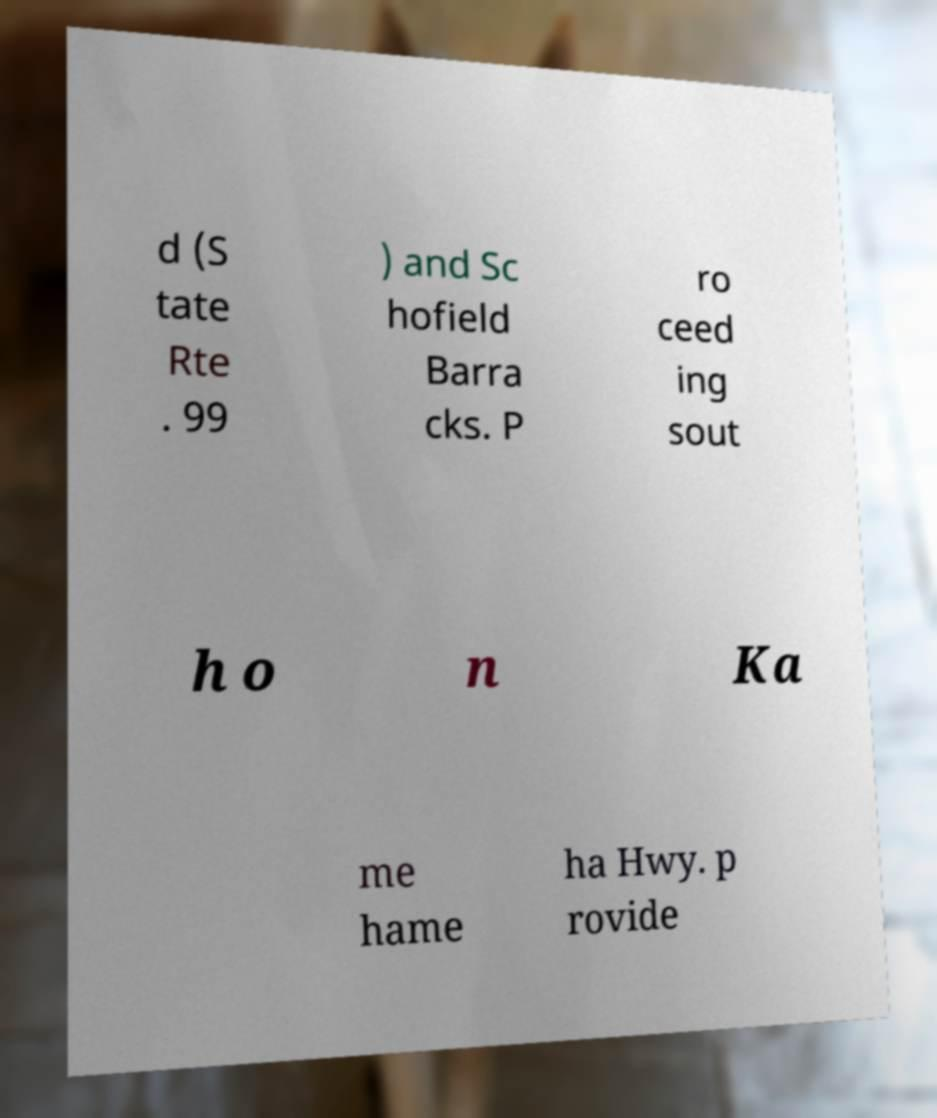What messages or text are displayed in this image? I need them in a readable, typed format. d (S tate Rte . 99 ) and Sc hofield Barra cks. P ro ceed ing sout h o n Ka me hame ha Hwy. p rovide 